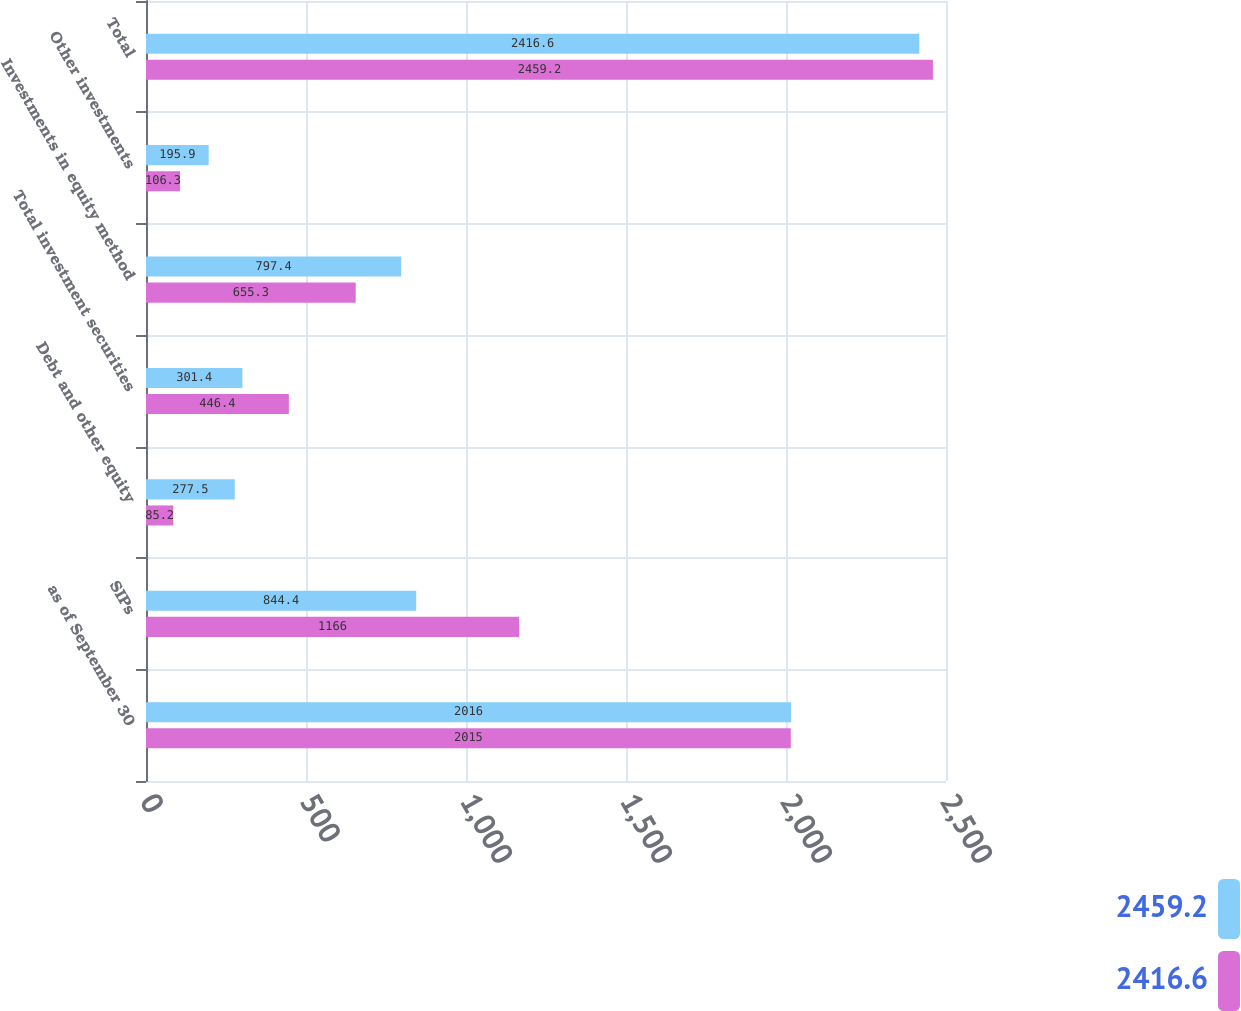Convert chart. <chart><loc_0><loc_0><loc_500><loc_500><stacked_bar_chart><ecel><fcel>as of September 30<fcel>SIPs<fcel>Debt and other equity<fcel>Total investment securities<fcel>Investments in equity method<fcel>Other investments<fcel>Total<nl><fcel>2459.2<fcel>2016<fcel>844.4<fcel>277.5<fcel>301.4<fcel>797.4<fcel>195.9<fcel>2416.6<nl><fcel>2416.6<fcel>2015<fcel>1166<fcel>85.2<fcel>446.4<fcel>655.3<fcel>106.3<fcel>2459.2<nl></chart> 